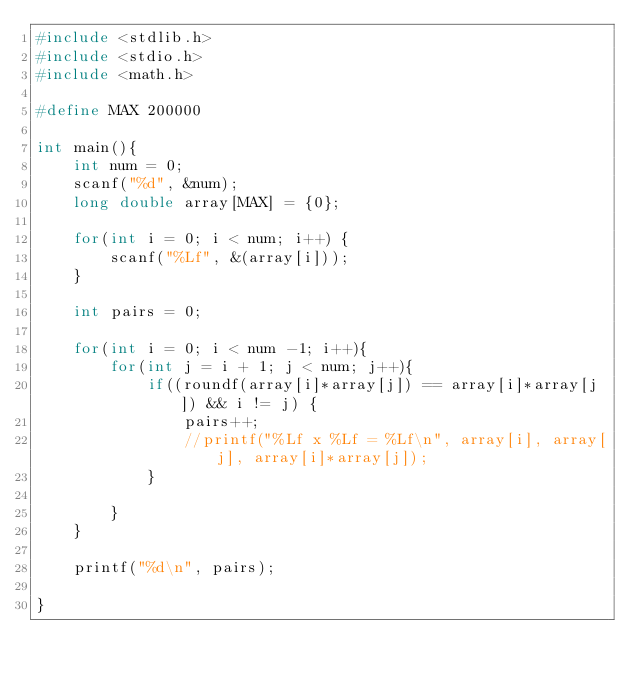<code> <loc_0><loc_0><loc_500><loc_500><_C_>#include <stdlib.h>
#include <stdio.h>
#include <math.h>

#define MAX 200000

int main(){
    int num = 0;
    scanf("%d", &num);
    long double array[MAX] = {0};

    for(int i = 0; i < num; i++) {
        scanf("%Lf", &(array[i]));
    }

    int pairs = 0;

    for(int i = 0; i < num -1; i++){
        for(int j = i + 1; j < num; j++){
            if((roundf(array[i]*array[j]) == array[i]*array[j]) && i != j) {
                pairs++;
                //printf("%Lf x %Lf = %Lf\n", array[i], array[j], array[i]*array[j]);
            }
            
        }
    }

    printf("%d\n", pairs);

}</code> 